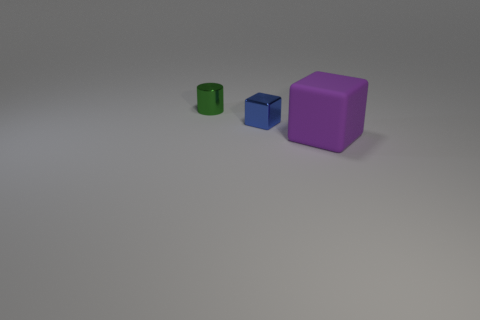Is the color of the tiny thing behind the blue cube the same as the large cube?
Offer a very short reply. No. There is a tiny green shiny object; how many purple rubber things are on the left side of it?
Provide a succinct answer. 0. Do the big purple cube and the blue block that is to the right of the small green metal thing have the same material?
Your answer should be very brief. No. What is the size of the blue object that is the same material as the cylinder?
Provide a short and direct response. Small. Is the number of metal blocks to the left of the metal cylinder greater than the number of rubber blocks in front of the big purple cube?
Ensure brevity in your answer.  No. Is there another tiny green object of the same shape as the rubber thing?
Keep it short and to the point. No. There is a thing left of the metallic cube; does it have the same size as the metal block?
Make the answer very short. Yes. Is there a tiny blue shiny thing?
Provide a short and direct response. Yes. How many things are either objects left of the large block or big matte blocks?
Offer a terse response. 3. There is a rubber thing; is it the same color as the block that is behind the big rubber thing?
Provide a succinct answer. No. 